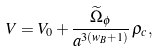Convert formula to latex. <formula><loc_0><loc_0><loc_500><loc_500>V = V _ { 0 } + \frac { \widetilde { \Omega } _ { \phi } } { a ^ { 3 ( w _ { B } + 1 ) } } \, \rho _ { c } ,</formula> 